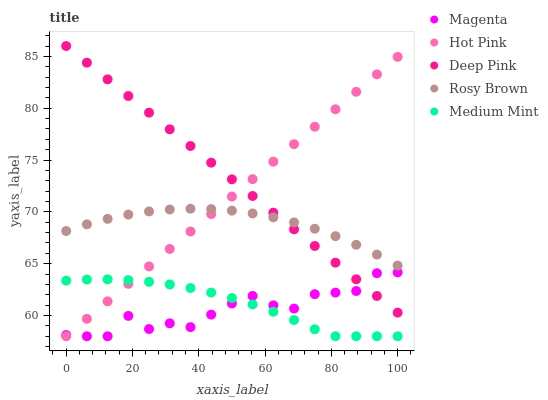Does Magenta have the minimum area under the curve?
Answer yes or no. Yes. Does Deep Pink have the maximum area under the curve?
Answer yes or no. Yes. Does Hot Pink have the minimum area under the curve?
Answer yes or no. No. Does Hot Pink have the maximum area under the curve?
Answer yes or no. No. Is Deep Pink the smoothest?
Answer yes or no. Yes. Is Magenta the roughest?
Answer yes or no. Yes. Is Hot Pink the smoothest?
Answer yes or no. No. Is Hot Pink the roughest?
Answer yes or no. No. Does Medium Mint have the lowest value?
Answer yes or no. Yes. Does Rosy Brown have the lowest value?
Answer yes or no. No. Does Deep Pink have the highest value?
Answer yes or no. Yes. Does Magenta have the highest value?
Answer yes or no. No. Is Medium Mint less than Deep Pink?
Answer yes or no. Yes. Is Deep Pink greater than Medium Mint?
Answer yes or no. Yes. Does Deep Pink intersect Hot Pink?
Answer yes or no. Yes. Is Deep Pink less than Hot Pink?
Answer yes or no. No. Is Deep Pink greater than Hot Pink?
Answer yes or no. No. Does Medium Mint intersect Deep Pink?
Answer yes or no. No. 